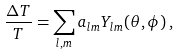<formula> <loc_0><loc_0><loc_500><loc_500>\frac { \Delta T } { T } = \sum _ { l , m } a _ { l m } Y _ { l m } ( \theta , \phi ) \, ,</formula> 